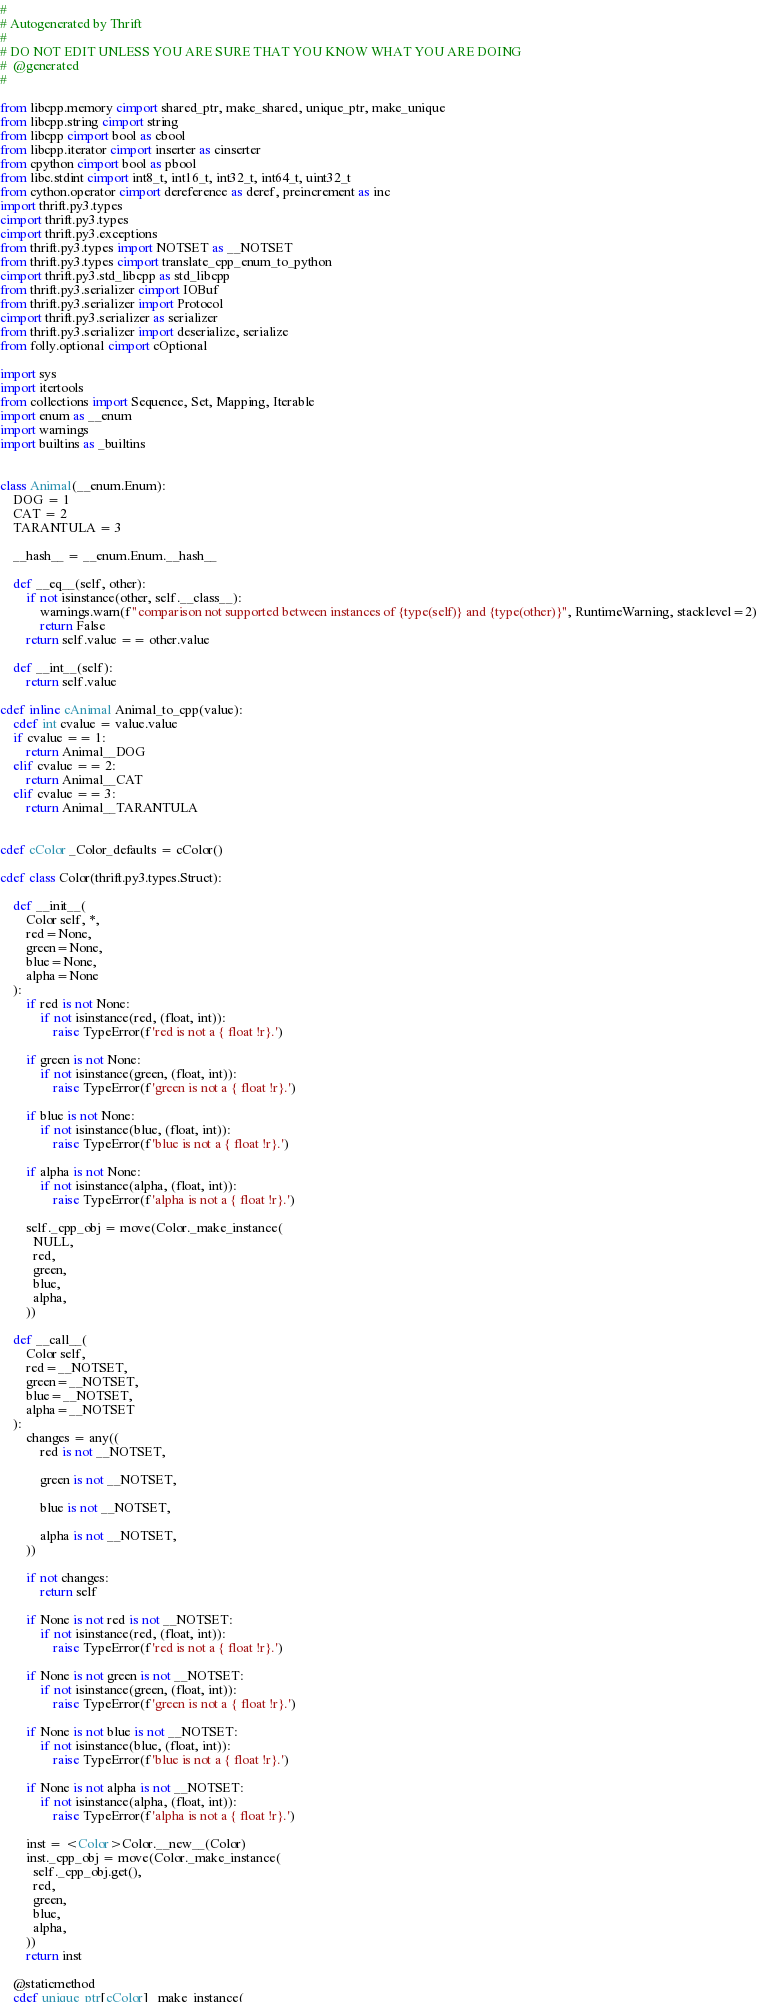Convert code to text. <code><loc_0><loc_0><loc_500><loc_500><_Cython_>#
# Autogenerated by Thrift
#
# DO NOT EDIT UNLESS YOU ARE SURE THAT YOU KNOW WHAT YOU ARE DOING
#  @generated
#

from libcpp.memory cimport shared_ptr, make_shared, unique_ptr, make_unique
from libcpp.string cimport string
from libcpp cimport bool as cbool
from libcpp.iterator cimport inserter as cinserter
from cpython cimport bool as pbool
from libc.stdint cimport int8_t, int16_t, int32_t, int64_t, uint32_t
from cython.operator cimport dereference as deref, preincrement as inc
import thrift.py3.types
cimport thrift.py3.types
cimport thrift.py3.exceptions
from thrift.py3.types import NOTSET as __NOTSET
from thrift.py3.types cimport translate_cpp_enum_to_python
cimport thrift.py3.std_libcpp as std_libcpp
from thrift.py3.serializer cimport IOBuf
from thrift.py3.serializer import Protocol
cimport thrift.py3.serializer as serializer
from thrift.py3.serializer import deserialize, serialize
from folly.optional cimport cOptional

import sys
import itertools
from collections import Sequence, Set, Mapping, Iterable
import enum as __enum
import warnings
import builtins as _builtins


class Animal(__enum.Enum):
    DOG = 1
    CAT = 2
    TARANTULA = 3

    __hash__ = __enum.Enum.__hash__

    def __eq__(self, other):
        if not isinstance(other, self.__class__):
            warnings.warn(f"comparison not supported between instances of {type(self)} and {type(other)}", RuntimeWarning, stacklevel=2)
            return False
        return self.value == other.value

    def __int__(self):
        return self.value

cdef inline cAnimal Animal_to_cpp(value):
    cdef int cvalue = value.value
    if cvalue == 1:
        return Animal__DOG
    elif cvalue == 2:
        return Animal__CAT
    elif cvalue == 3:
        return Animal__TARANTULA


cdef cColor _Color_defaults = cColor()

cdef class Color(thrift.py3.types.Struct):

    def __init__(
        Color self, *,
        red=None,
        green=None,
        blue=None,
        alpha=None
    ):
        if red is not None:
            if not isinstance(red, (float, int)):
                raise TypeError(f'red is not a { float !r}.')

        if green is not None:
            if not isinstance(green, (float, int)):
                raise TypeError(f'green is not a { float !r}.')

        if blue is not None:
            if not isinstance(blue, (float, int)):
                raise TypeError(f'blue is not a { float !r}.')

        if alpha is not None:
            if not isinstance(alpha, (float, int)):
                raise TypeError(f'alpha is not a { float !r}.')

        self._cpp_obj = move(Color._make_instance(
          NULL,
          red,
          green,
          blue,
          alpha,
        ))

    def __call__(
        Color self,
        red=__NOTSET,
        green=__NOTSET,
        blue=__NOTSET,
        alpha=__NOTSET
    ):
        changes = any((
            red is not __NOTSET,

            green is not __NOTSET,

            blue is not __NOTSET,

            alpha is not __NOTSET,
        ))

        if not changes:
            return self

        if None is not red is not __NOTSET:
            if not isinstance(red, (float, int)):
                raise TypeError(f'red is not a { float !r}.')

        if None is not green is not __NOTSET:
            if not isinstance(green, (float, int)):
                raise TypeError(f'green is not a { float !r}.')

        if None is not blue is not __NOTSET:
            if not isinstance(blue, (float, int)):
                raise TypeError(f'blue is not a { float !r}.')

        if None is not alpha is not __NOTSET:
            if not isinstance(alpha, (float, int)):
                raise TypeError(f'alpha is not a { float !r}.')

        inst = <Color>Color.__new__(Color)
        inst._cpp_obj = move(Color._make_instance(
          self._cpp_obj.get(),
          red,
          green,
          blue,
          alpha,
        ))
        return inst

    @staticmethod
    cdef unique_ptr[cColor] _make_instance(</code> 